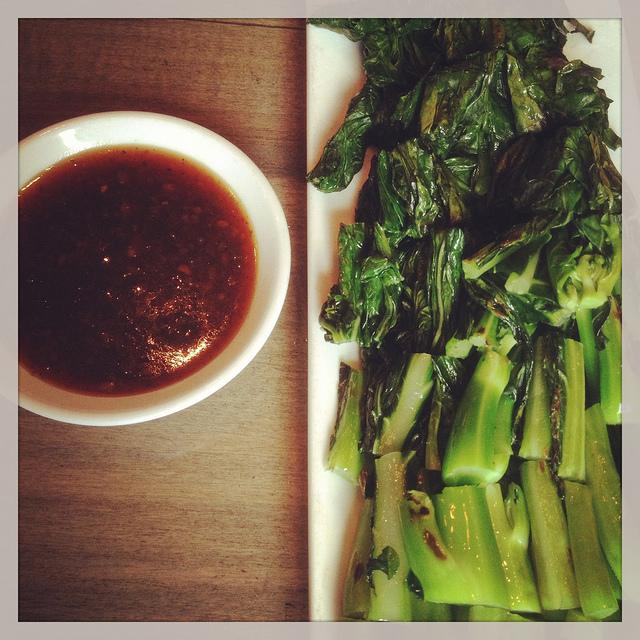What is about to be dipped?

Choices:
A) cheese
B) broccoli
C) dunkaroos
D) swimmer broccoli 